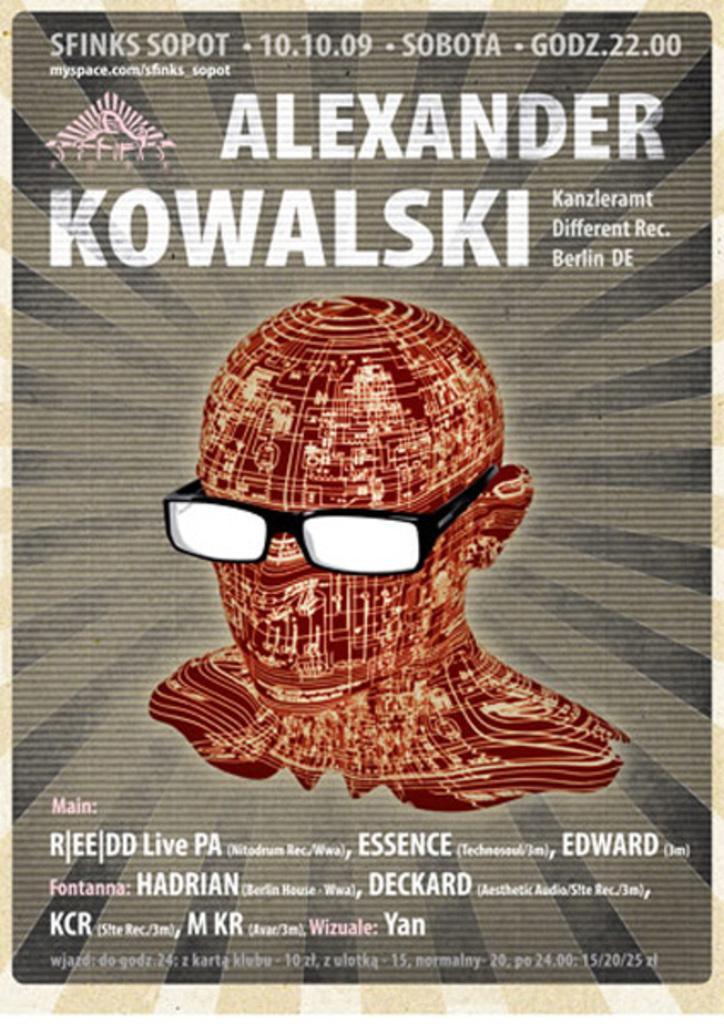What is featured in the image? There is a poster in the image. What can be found on the poster? The poster contains text and an animation of a person. How many bikes are shown in the animation on the poster? There are no bikes present in the image or the animation on the poster. 